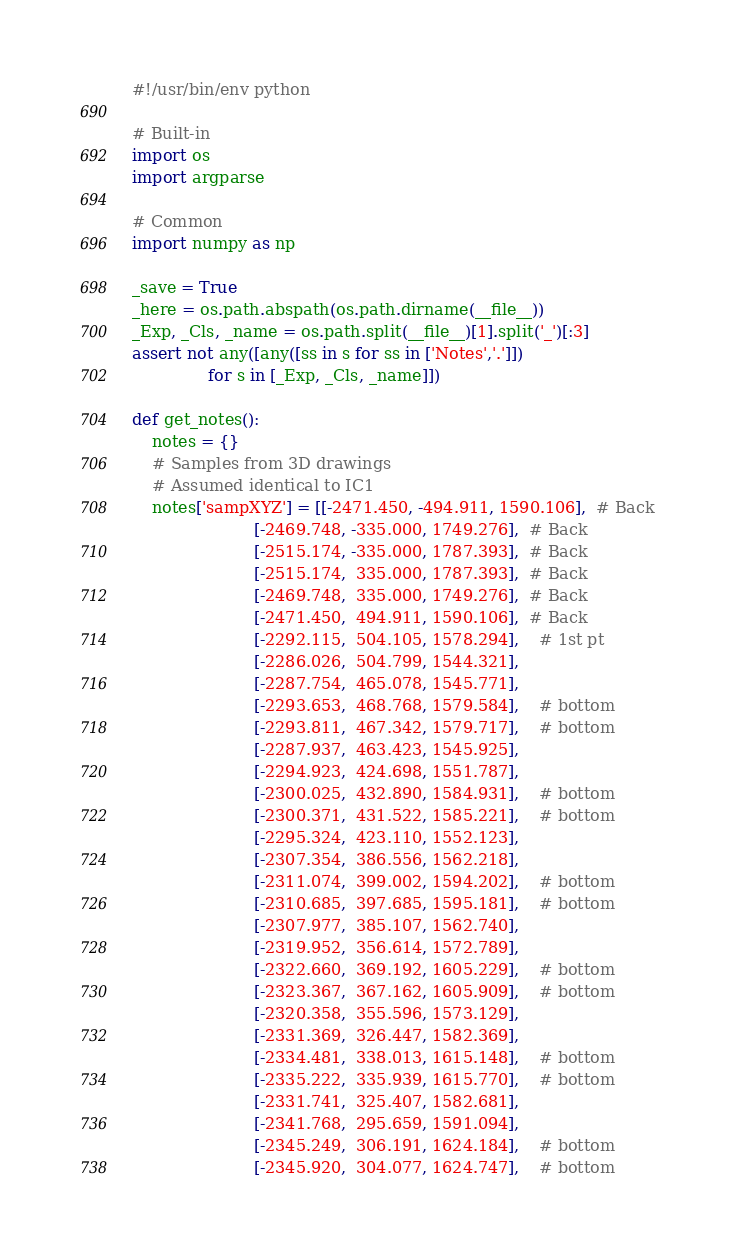<code> <loc_0><loc_0><loc_500><loc_500><_Python_>#!/usr/bin/env python

# Built-in
import os
import argparse

# Common
import numpy as np

_save = True
_here = os.path.abspath(os.path.dirname(__file__))
_Exp, _Cls, _name = os.path.split(__file__)[1].split('_')[:3]
assert not any([any([ss in s for ss in ['Notes','.']])
               for s in [_Exp, _Cls, _name]])

def get_notes():
    notes = {}
    # Samples from 3D drawings
    # Assumed identical to IC1
    notes['sampXYZ'] = [[-2471.450, -494.911, 1590.106],  # Back
                        [-2469.748, -335.000, 1749.276],  # Back
                        [-2515.174, -335.000, 1787.393],  # Back
                        [-2515.174,  335.000, 1787.393],  # Back
                        [-2469.748,  335.000, 1749.276],  # Back
                        [-2471.450,  494.911, 1590.106],  # Back
                        [-2292.115,  504.105, 1578.294],    # 1st pt
                        [-2286.026,  504.799, 1544.321],
                        [-2287.754,  465.078, 1545.771],
                        [-2293.653,  468.768, 1579.584],    # bottom
                        [-2293.811,  467.342, 1579.717],    # bottom
                        [-2287.937,  463.423, 1545.925],
                        [-2294.923,  424.698, 1551.787],
                        [-2300.025,  432.890, 1584.931],    # bottom
                        [-2300.371,  431.522, 1585.221],    # bottom
                        [-2295.324,  423.110, 1552.123],
                        [-2307.354,  386.556, 1562.218],
                        [-2311.074,  399.002, 1594.202],    # bottom
                        [-2310.685,  397.685, 1595.181],    # bottom
                        [-2307.977,  385.107, 1562.740],
                        [-2319.952,  356.614, 1572.789],
                        [-2322.660,  369.192, 1605.229],    # bottom
                        [-2323.367,  367.162, 1605.909],    # bottom
                        [-2320.358,  355.596, 1573.129],
                        [-2331.369,  326.447, 1582.369],
                        [-2334.481,  338.013, 1615.148],    # bottom
                        [-2335.222,  335.939, 1615.770],    # bottom
                        [-2331.741,  325.407, 1582.681],
                        [-2341.768,  295.659, 1591.094],
                        [-2345.249,  306.191, 1624.184],    # bottom
                        [-2345.920,  304.077, 1624.747],    # bottom</code> 